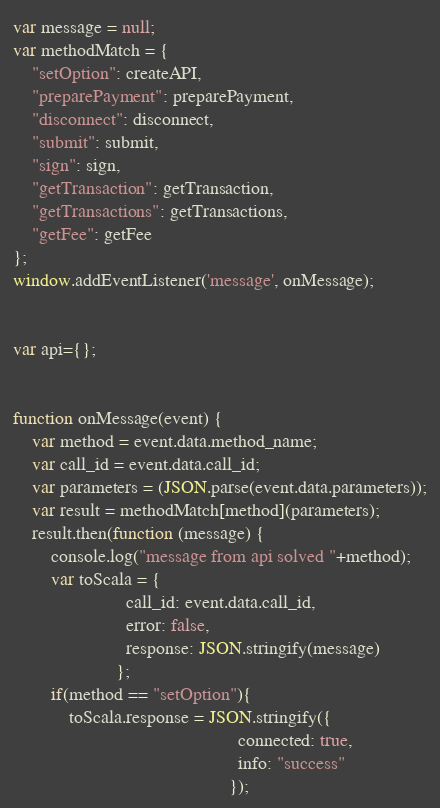Convert code to text. <code><loc_0><loc_0><loc_500><loc_500><_JavaScript_>
var message = null;
var methodMatch = {
    "setOption": createAPI,
    "preparePayment": preparePayment,
    "disconnect": disconnect,
    "submit": submit,
    "sign": sign,
    "getTransaction": getTransaction,
    "getTransactions": getTransactions,
    "getFee": getFee
};
window.addEventListener('message', onMessage);


var api={};


function onMessage(event) {
    var method = event.data.method_name;
    var call_id = event.data.call_id;
    var parameters = (JSON.parse(event.data.parameters));
    var result = methodMatch[method](parameters);
    result.then(function (message) {
        console.log("message from api solved "+method);
        var toScala = {
                        call_id: event.data.call_id,
                        error: false,
                        response: JSON.stringify(message)
                      };
        if(method == "setOption"){
            toScala.response = JSON.stringify({
                                                connected: true,
                                                info: "success"
                                              });</code> 